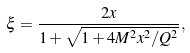Convert formula to latex. <formula><loc_0><loc_0><loc_500><loc_500>\xi = \frac { 2 x } { 1 + \sqrt { 1 + 4 M ^ { 2 } x ^ { 2 } / Q ^ { 2 } } } ,</formula> 